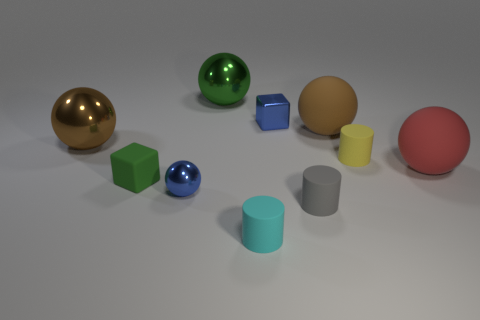Subtract all red spheres. How many spheres are left? 4 Subtract all big green balls. How many balls are left? 4 Subtract all cyan balls. Subtract all red blocks. How many balls are left? 5 Subtract all blocks. How many objects are left? 8 Subtract 0 red blocks. How many objects are left? 10 Subtract all tiny gray cubes. Subtract all big green metallic balls. How many objects are left? 9 Add 4 large green things. How many large green things are left? 5 Add 5 large brown things. How many large brown things exist? 7 